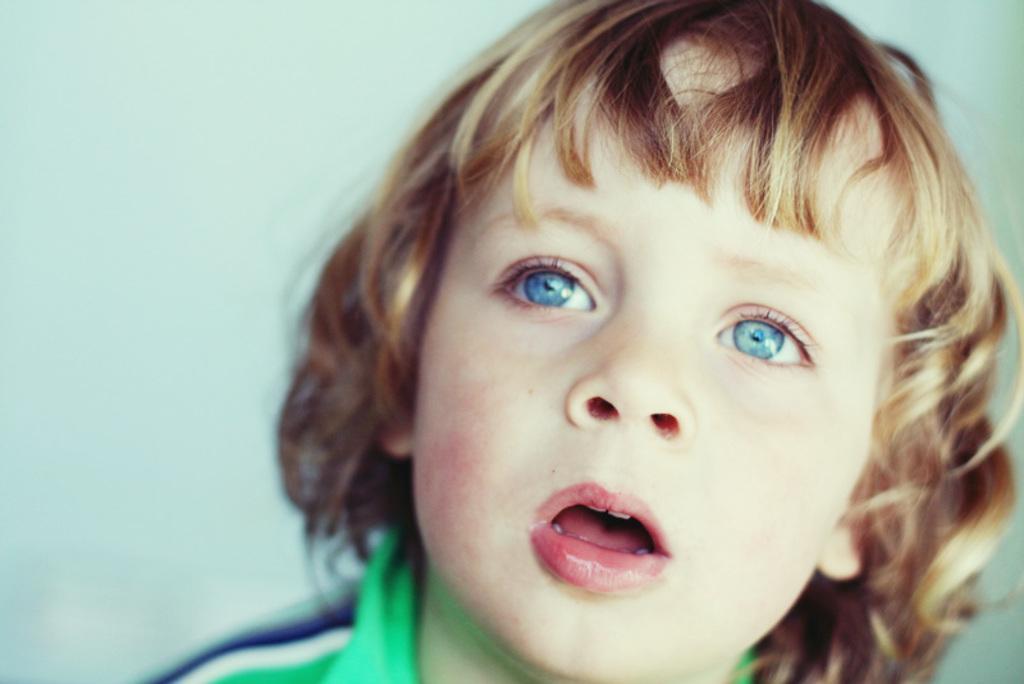Describe this image in one or two sentences. In this image, we can see a kid wearing a green color shirt. In the background, we can see blue color. 